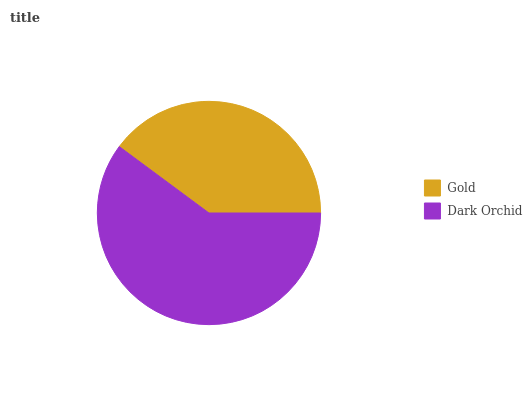Is Gold the minimum?
Answer yes or no. Yes. Is Dark Orchid the maximum?
Answer yes or no. Yes. Is Dark Orchid the minimum?
Answer yes or no. No. Is Dark Orchid greater than Gold?
Answer yes or no. Yes. Is Gold less than Dark Orchid?
Answer yes or no. Yes. Is Gold greater than Dark Orchid?
Answer yes or no. No. Is Dark Orchid less than Gold?
Answer yes or no. No. Is Dark Orchid the high median?
Answer yes or no. Yes. Is Gold the low median?
Answer yes or no. Yes. Is Gold the high median?
Answer yes or no. No. Is Dark Orchid the low median?
Answer yes or no. No. 